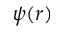<formula> <loc_0><loc_0><loc_500><loc_500>\psi ( r )</formula> 